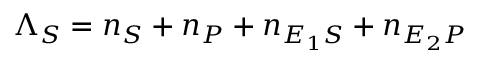Convert formula to latex. <formula><loc_0><loc_0><loc_500><loc_500>\Lambda _ { S } = n _ { S } + n _ { P } + n _ { E _ { 1 } S } + n _ { E _ { 2 } P }</formula> 